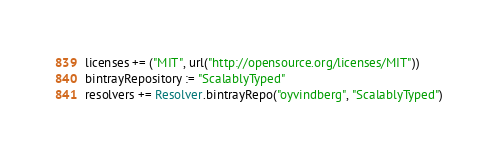Convert code to text. <code><loc_0><loc_0><loc_500><loc_500><_Scala_>licenses += ("MIT", url("http://opensource.org/licenses/MIT"))
bintrayRepository := "ScalablyTyped"
resolvers += Resolver.bintrayRepo("oyvindberg", "ScalablyTyped")
</code> 